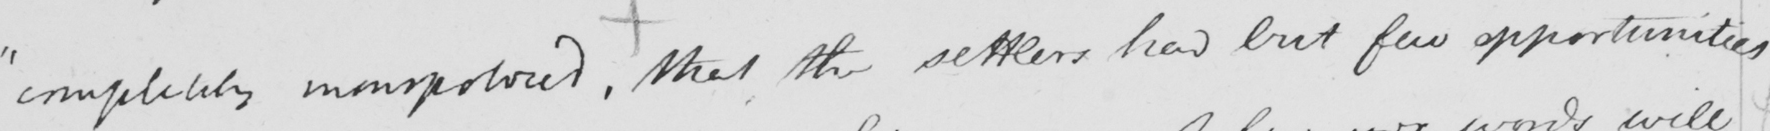Please provide the text content of this handwritten line. " completely monopolized ,  that the settlers had but few opportunities 